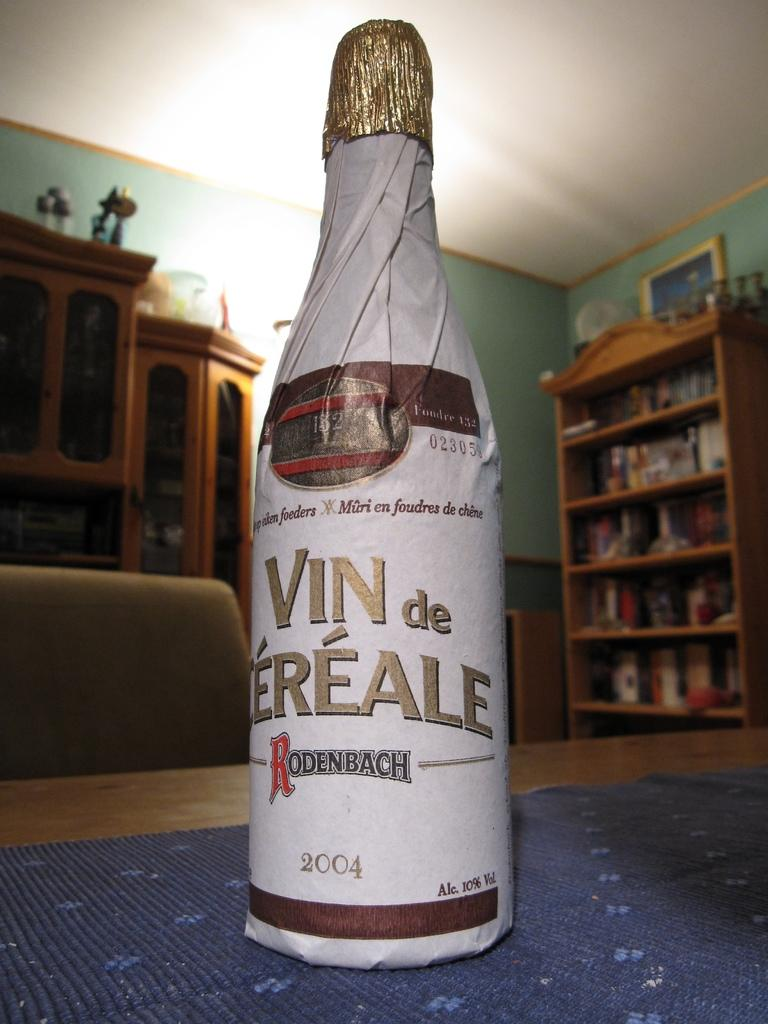<image>
Relay a brief, clear account of the picture shown. An unopened bottle of Vin de Vereale Rodenbach from 2004 covered with white wrapping. 